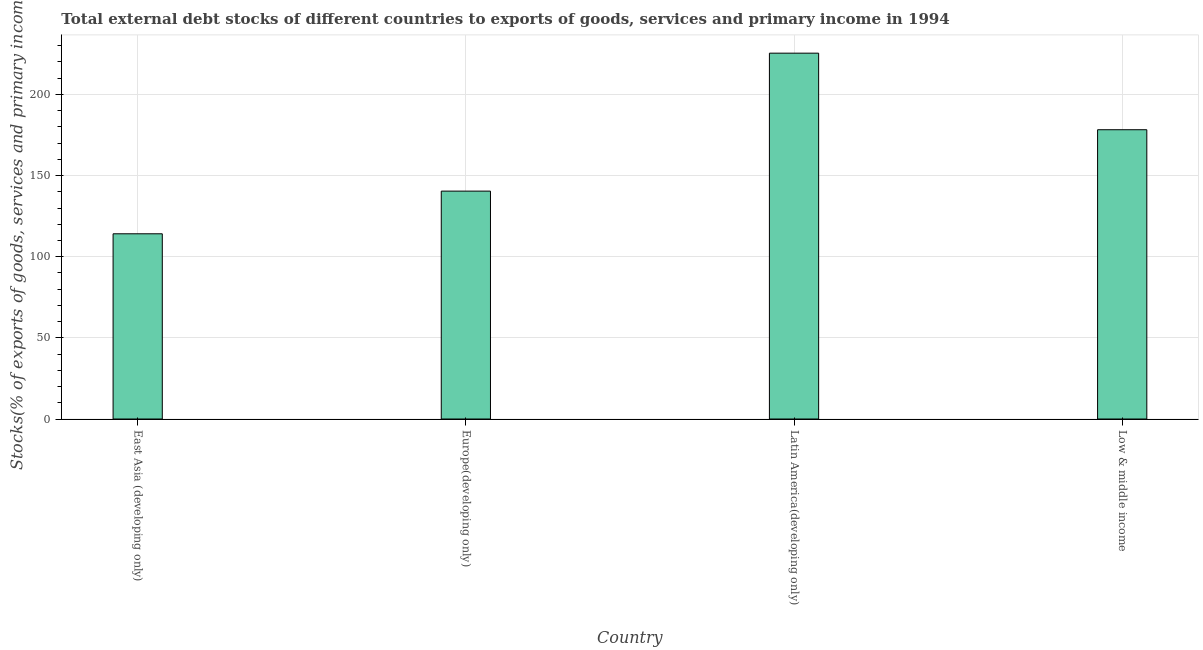Does the graph contain grids?
Offer a terse response. Yes. What is the title of the graph?
Your answer should be compact. Total external debt stocks of different countries to exports of goods, services and primary income in 1994. What is the label or title of the Y-axis?
Keep it short and to the point. Stocks(% of exports of goods, services and primary income). What is the external debt stocks in Latin America(developing only)?
Make the answer very short. 225.43. Across all countries, what is the maximum external debt stocks?
Offer a very short reply. 225.43. Across all countries, what is the minimum external debt stocks?
Provide a succinct answer. 114.14. In which country was the external debt stocks maximum?
Provide a succinct answer. Latin America(developing only). In which country was the external debt stocks minimum?
Provide a short and direct response. East Asia (developing only). What is the sum of the external debt stocks?
Make the answer very short. 658.25. What is the difference between the external debt stocks in Europe(developing only) and Latin America(developing only)?
Keep it short and to the point. -85.01. What is the average external debt stocks per country?
Offer a terse response. 164.56. What is the median external debt stocks?
Keep it short and to the point. 159.34. In how many countries, is the external debt stocks greater than 110 %?
Your answer should be very brief. 4. What is the ratio of the external debt stocks in Europe(developing only) to that in Latin America(developing only)?
Offer a very short reply. 0.62. What is the difference between the highest and the second highest external debt stocks?
Provide a short and direct response. 47.17. What is the difference between the highest and the lowest external debt stocks?
Your answer should be very brief. 111.3. In how many countries, is the external debt stocks greater than the average external debt stocks taken over all countries?
Make the answer very short. 2. How many bars are there?
Offer a very short reply. 4. How many countries are there in the graph?
Provide a succinct answer. 4. What is the difference between two consecutive major ticks on the Y-axis?
Give a very brief answer. 50. What is the Stocks(% of exports of goods, services and primary income) of East Asia (developing only)?
Your answer should be compact. 114.14. What is the Stocks(% of exports of goods, services and primary income) of Europe(developing only)?
Offer a terse response. 140.43. What is the Stocks(% of exports of goods, services and primary income) in Latin America(developing only)?
Offer a very short reply. 225.43. What is the Stocks(% of exports of goods, services and primary income) of Low & middle income?
Ensure brevity in your answer.  178.26. What is the difference between the Stocks(% of exports of goods, services and primary income) in East Asia (developing only) and Europe(developing only)?
Give a very brief answer. -26.29. What is the difference between the Stocks(% of exports of goods, services and primary income) in East Asia (developing only) and Latin America(developing only)?
Provide a short and direct response. -111.3. What is the difference between the Stocks(% of exports of goods, services and primary income) in East Asia (developing only) and Low & middle income?
Make the answer very short. -64.12. What is the difference between the Stocks(% of exports of goods, services and primary income) in Europe(developing only) and Latin America(developing only)?
Give a very brief answer. -85.01. What is the difference between the Stocks(% of exports of goods, services and primary income) in Europe(developing only) and Low & middle income?
Your answer should be compact. -37.83. What is the difference between the Stocks(% of exports of goods, services and primary income) in Latin America(developing only) and Low & middle income?
Provide a succinct answer. 47.17. What is the ratio of the Stocks(% of exports of goods, services and primary income) in East Asia (developing only) to that in Europe(developing only)?
Give a very brief answer. 0.81. What is the ratio of the Stocks(% of exports of goods, services and primary income) in East Asia (developing only) to that in Latin America(developing only)?
Ensure brevity in your answer.  0.51. What is the ratio of the Stocks(% of exports of goods, services and primary income) in East Asia (developing only) to that in Low & middle income?
Give a very brief answer. 0.64. What is the ratio of the Stocks(% of exports of goods, services and primary income) in Europe(developing only) to that in Latin America(developing only)?
Offer a very short reply. 0.62. What is the ratio of the Stocks(% of exports of goods, services and primary income) in Europe(developing only) to that in Low & middle income?
Your response must be concise. 0.79. What is the ratio of the Stocks(% of exports of goods, services and primary income) in Latin America(developing only) to that in Low & middle income?
Make the answer very short. 1.26. 